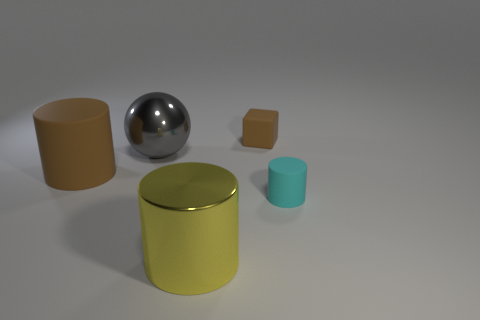There is a big object that is the same color as the matte cube; what is its material?
Ensure brevity in your answer.  Rubber. There is a brown thing behind the matte cylinder on the left side of the metal cylinder; what shape is it?
Keep it short and to the point. Cube. Is there a cyan rubber object of the same shape as the big gray object?
Offer a very short reply. No. How many yellow things are there?
Offer a very short reply. 1. Are the brown object to the left of the small brown thing and the tiny cyan thing made of the same material?
Provide a succinct answer. Yes. Are there any green shiny things of the same size as the gray shiny thing?
Ensure brevity in your answer.  No. There is a small brown matte thing; is it the same shape as the small rubber thing in front of the big ball?
Offer a very short reply. No. There is a matte cylinder that is to the right of the matte object that is behind the large brown rubber cylinder; are there any large balls that are on the right side of it?
Provide a succinct answer. No. What size is the metallic cylinder?
Your answer should be very brief. Large. How many other things are the same color as the big rubber cylinder?
Your response must be concise. 1. 